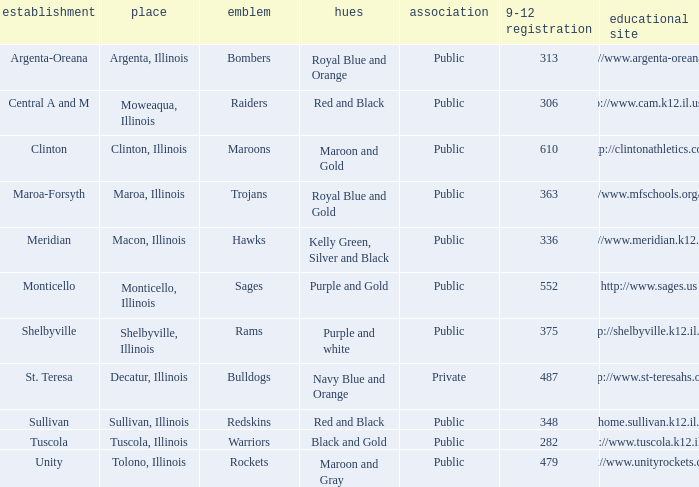What location has 363 students enrolled in the 9th to 12th grades? Maroa, Illinois. 